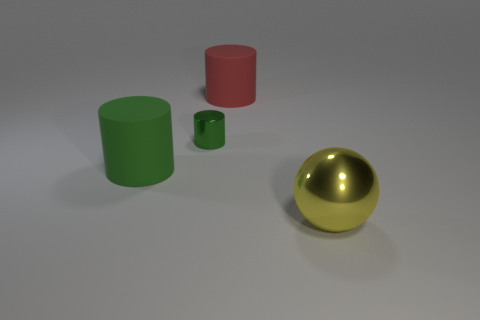Subtract all matte cylinders. How many cylinders are left? 1 Add 1 large green shiny things. How many objects exist? 5 Subtract all spheres. How many objects are left? 3 Subtract 0 gray cylinders. How many objects are left? 4 Subtract all small brown rubber cylinders. Subtract all big yellow shiny objects. How many objects are left? 3 Add 3 large yellow metal objects. How many large yellow metal objects are left? 4 Add 3 small shiny balls. How many small shiny balls exist? 3 